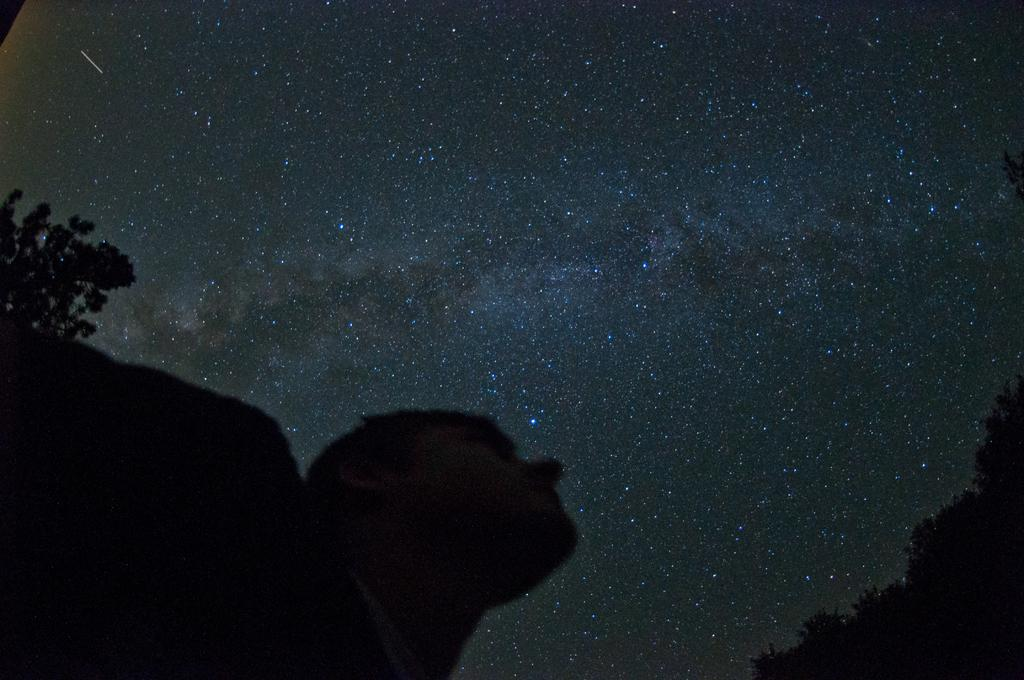What is the main subject of the image? There is a person in the image. What can be seen in the background on both sides of the person? There are trees on either side of the person. What is visible in the sky in the image? There are stars visible in the sky. What type of advertisement can be seen on the person's spoon in the image? There is no spoon present in the image, and therefore no advertisement can be seen on it. 